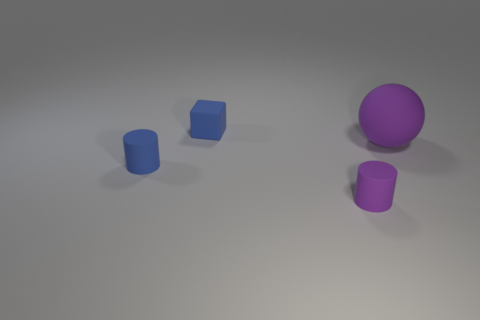Add 2 tiny cyan shiny balls. How many objects exist? 6 Subtract all blocks. How many objects are left? 3 Add 4 big brown objects. How many big brown objects exist? 4 Subtract 0 yellow cubes. How many objects are left? 4 Subtract all tiny purple rubber things. Subtract all big things. How many objects are left? 2 Add 3 large purple rubber spheres. How many large purple rubber spheres are left? 4 